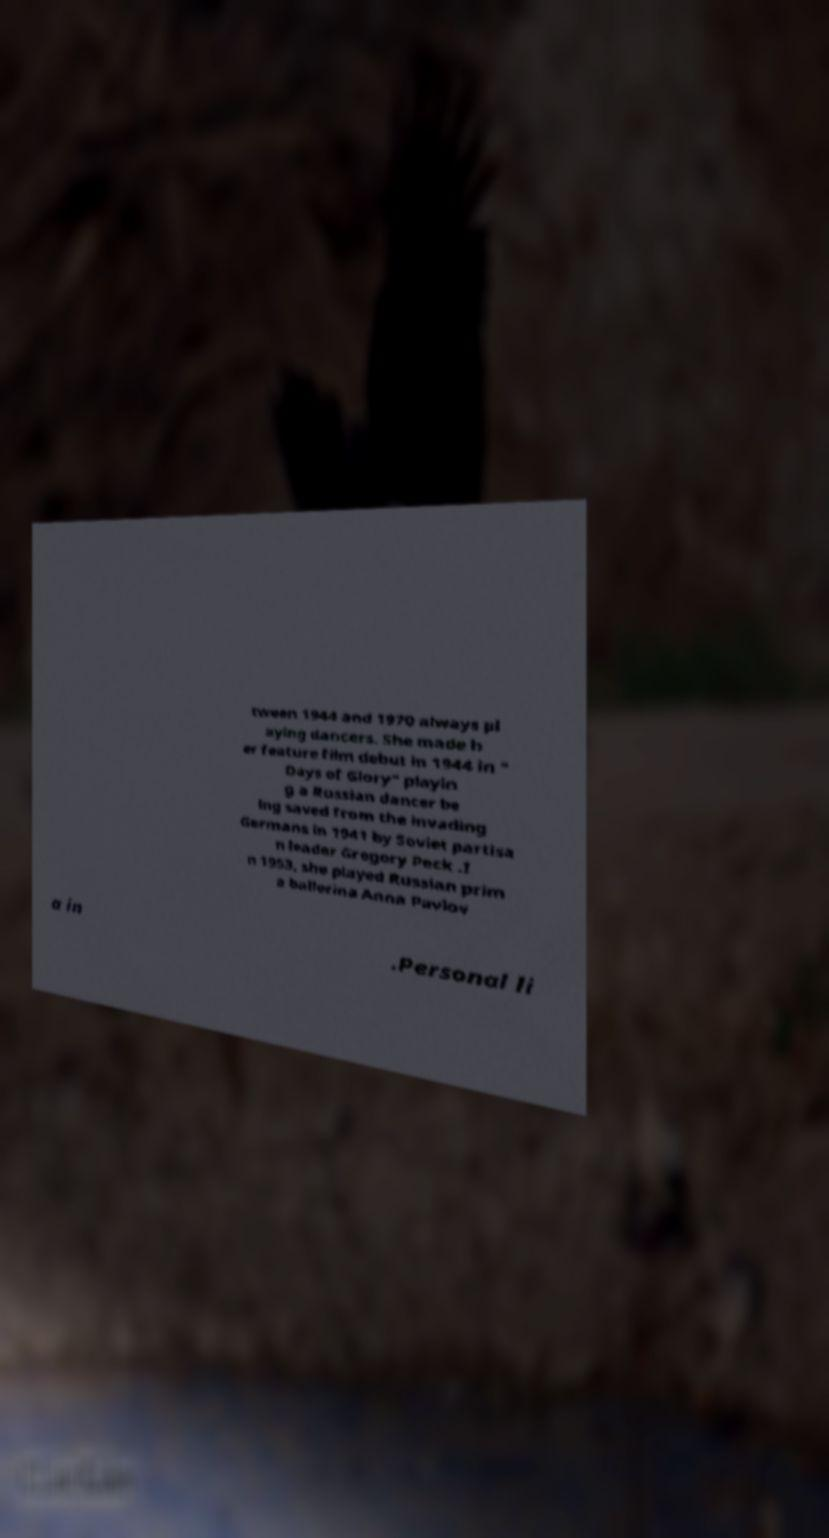For documentation purposes, I need the text within this image transcribed. Could you provide that? tween 1944 and 1970 always pl aying dancers. She made h er feature film debut in 1944 in " Days of Glory" playin g a Russian dancer be ing saved from the invading Germans in 1941 by Soviet partisa n leader Gregory Peck .I n 1953, she played Russian prim a ballerina Anna Pavlov a in .Personal li 